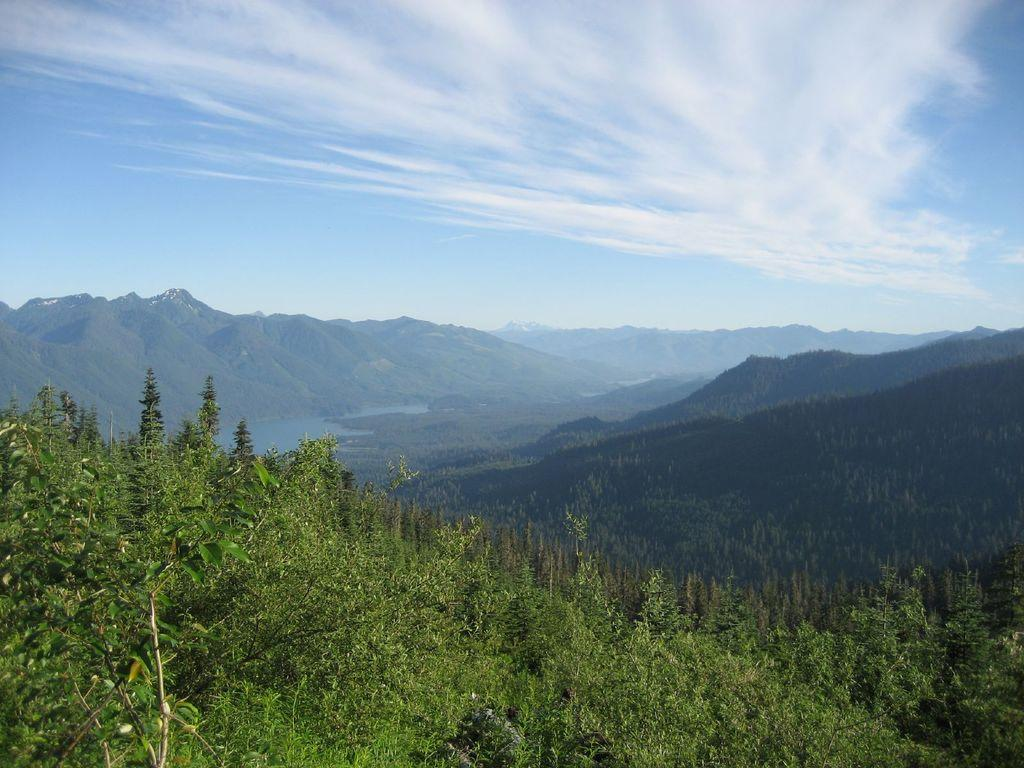What type of vegetation can be seen in the image? There are trees in the image. What is the color of the trees? The trees are green in color. What else can be seen besides trees in the image? There is water visible in the image, as well as mountains and the sky. What type of pet is sitting on the property in the image? There is no pet or property present in the image; it features trees, water, mountains, and the sky. 